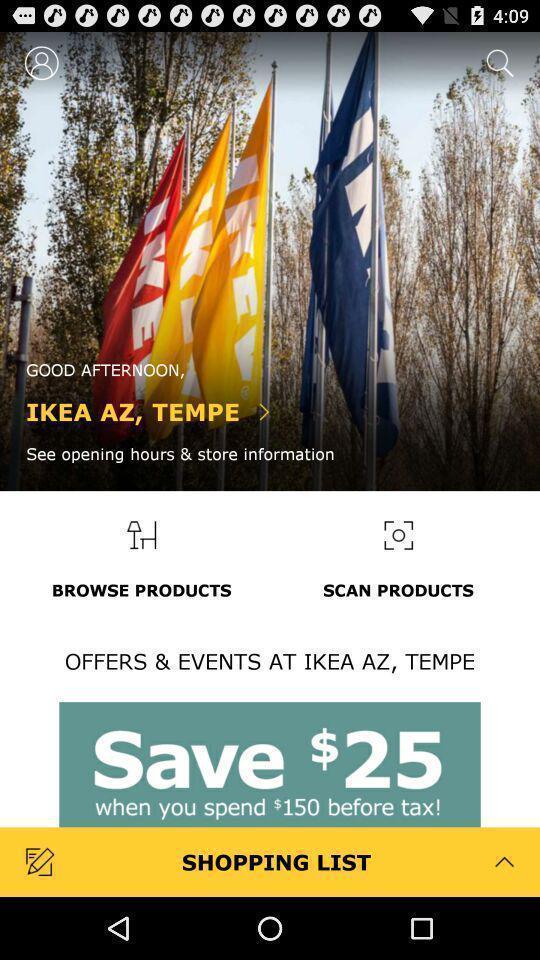Describe this image in words. Welcome page for a furniture shopping app. 